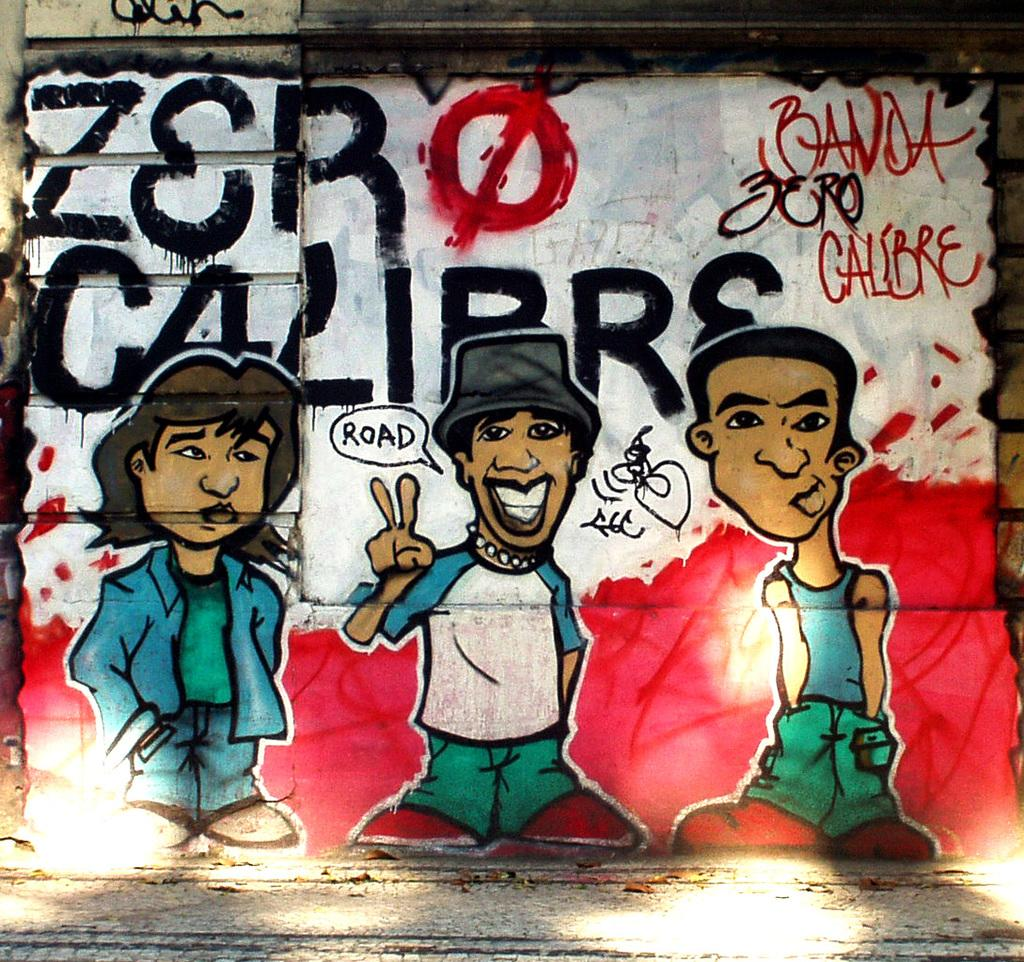What is the main subject of the image? The main subject of the image is a painting. What is depicted in the painting? The painting contains three cartoon persons. Are there any words or letters on the painting? Yes, there is text written on the painting. What type of space suit is the judge wearing in the image? There is no judge or space suit present in the image; it features a painting with three cartoon persons and text. 